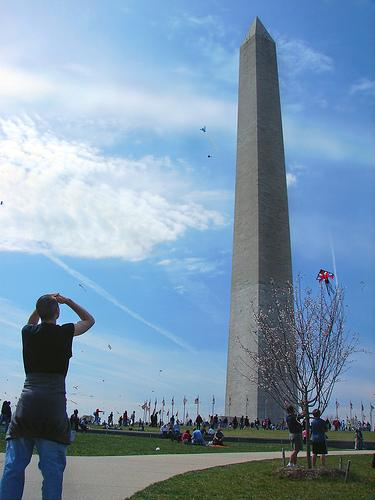What kind of people visit this place throughout the year? tourists 